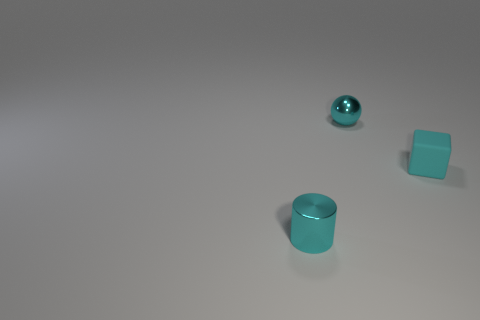Add 3 large green rubber things. How many objects exist? 6 Subtract all cylinders. How many objects are left? 2 Add 1 small things. How many small things exist? 4 Subtract 0 gray balls. How many objects are left? 3 Subtract all tiny purple spheres. Subtract all tiny cyan cylinders. How many objects are left? 2 Add 1 tiny metallic spheres. How many tiny metallic spheres are left? 2 